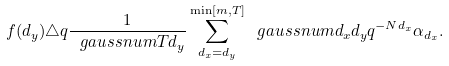<formula> <loc_0><loc_0><loc_500><loc_500>f ( d _ { y } ) \triangle q \frac { 1 } { \ g a u s s n u m { T } { d _ { y } } } \sum _ { d _ { x } = d _ { y } } ^ { \min [ m , T ] } \ g a u s s n u m { d _ { x } } { d _ { y } } q ^ { - N d _ { x } } \alpha _ { d _ { x } } .</formula> 